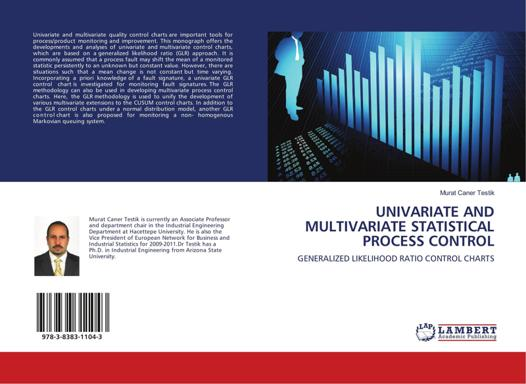What might be the content of this book? The publication delves into the complex statistical methodologies used to monitor changes and maintain control over industrial processes. It likely covers foundational concepts in statistics such as hypothesis testing and process optimization, while also discussing the practical applications of univariate and multivariate statistical methods. Particular emphasis is placed on Generalized Likelihood Ratio Control Charts, which serve as advanced tools for detecting variations in data, crucial for quality assurance in production environments. 